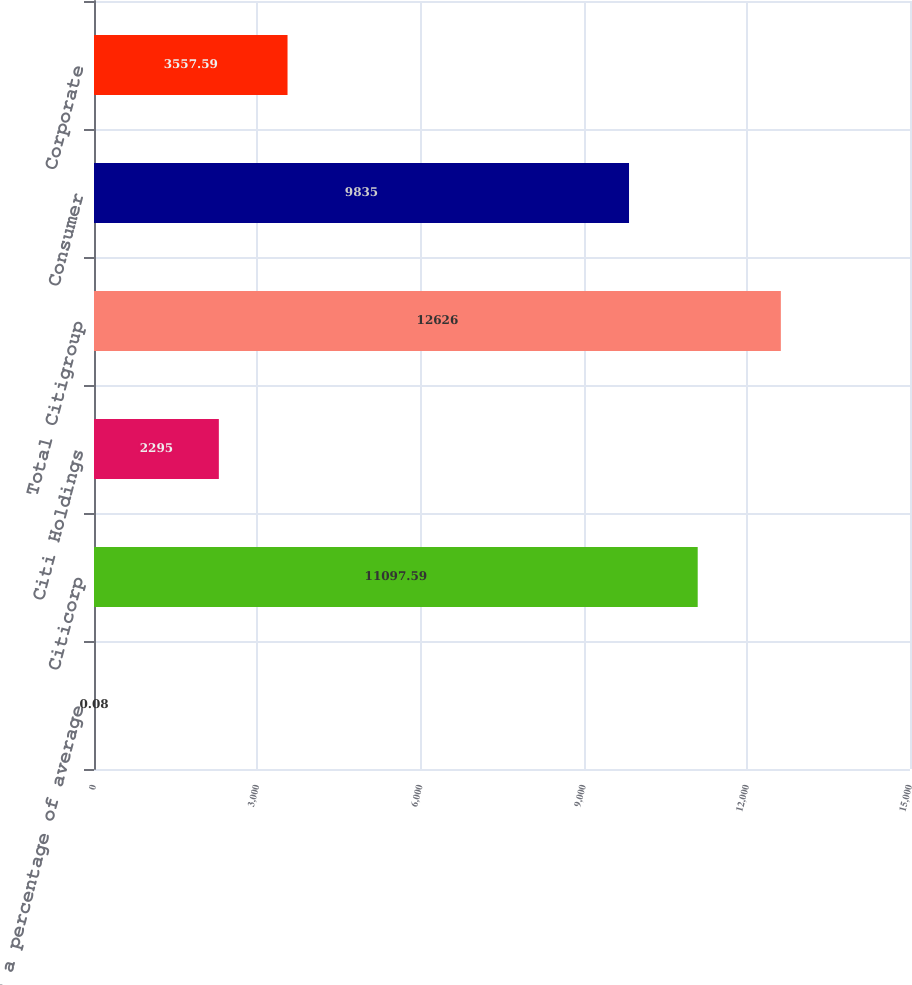Convert chart. <chart><loc_0><loc_0><loc_500><loc_500><bar_chart><fcel>As a percentage of average<fcel>Citicorp<fcel>Citi Holdings<fcel>Total Citigroup<fcel>Consumer<fcel>Corporate<nl><fcel>0.08<fcel>11097.6<fcel>2295<fcel>12626<fcel>9835<fcel>3557.59<nl></chart> 